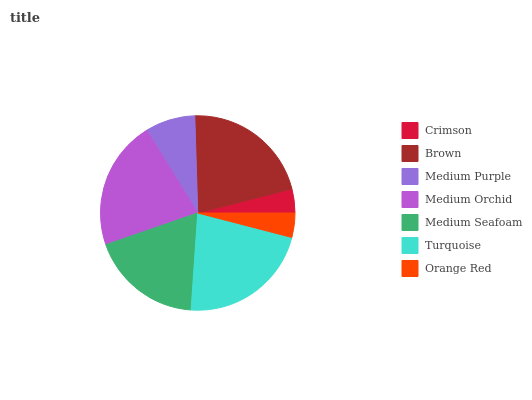Is Crimson the minimum?
Answer yes or no. Yes. Is Turquoise the maximum?
Answer yes or no. Yes. Is Brown the minimum?
Answer yes or no. No. Is Brown the maximum?
Answer yes or no. No. Is Brown greater than Crimson?
Answer yes or no. Yes. Is Crimson less than Brown?
Answer yes or no. Yes. Is Crimson greater than Brown?
Answer yes or no. No. Is Brown less than Crimson?
Answer yes or no. No. Is Medium Seafoam the high median?
Answer yes or no. Yes. Is Medium Seafoam the low median?
Answer yes or no. Yes. Is Brown the high median?
Answer yes or no. No. Is Crimson the low median?
Answer yes or no. No. 